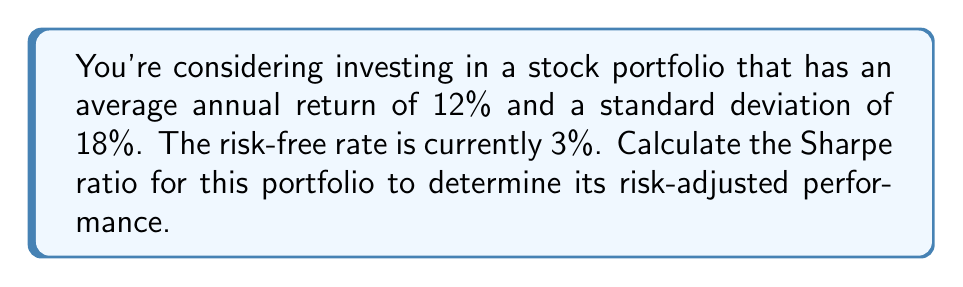What is the answer to this math problem? As a personal finance enthusiast, understanding the Sharpe ratio can help you evaluate the performance of your investments relative to their risk. Let's break down the calculation:

1. The Sharpe ratio is calculated using the following formula:

   $$S = \frac{R_p - R_f}{\sigma_p}$$

   Where:
   $S$ = Sharpe ratio
   $R_p$ = Portfolio return
   $R_f$ = Risk-free rate
   $\sigma_p$ = Portfolio standard deviation (volatility)

2. We're given the following information:
   - Portfolio return ($R_p$) = 12%
   - Risk-free rate ($R_f$) = 3%
   - Portfolio standard deviation ($\sigma_p$) = 18%

3. Let's substitute these values into the formula:

   $$S = \frac{0.12 - 0.03}{0.18}$$

4. First, calculate the numerator:
   
   $$0.12 - 0.03 = 0.09$$

5. Now, divide by the standard deviation:

   $$S = \frac{0.09}{0.18} = 0.5$$

The Sharpe ratio for this portfolio is 0.5. This means that for every unit of risk (volatility) taken, the portfolio is generating 0.5 units of excess return over the risk-free rate.
Answer: The Sharpe ratio for the given portfolio is 0.5. 